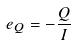<formula> <loc_0><loc_0><loc_500><loc_500>e _ { Q } = - \frac { Q } { I }</formula> 